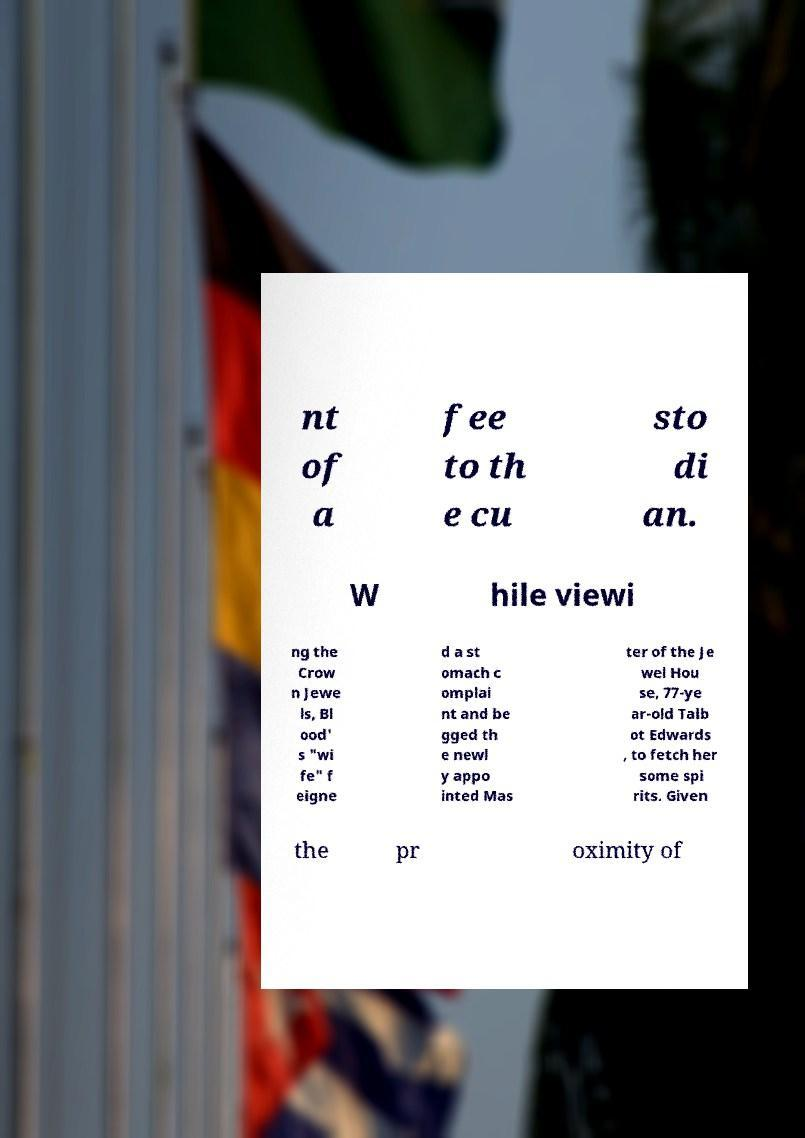Please read and relay the text visible in this image. What does it say? nt of a fee to th e cu sto di an. W hile viewi ng the Crow n Jewe ls, Bl ood' s "wi fe" f eigne d a st omach c omplai nt and be gged th e newl y appo inted Mas ter of the Je wel Hou se, 77-ye ar-old Talb ot Edwards , to fetch her some spi rits. Given the pr oximity of 